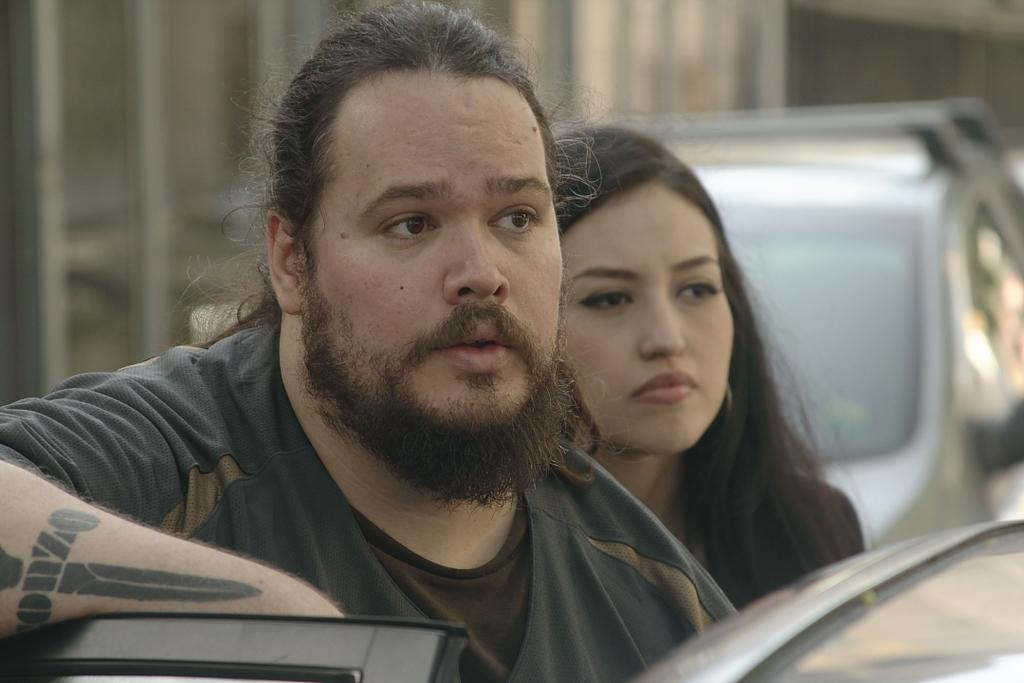Who or what is present in the image? There are people in the image. What are the people doing in the image? The people are staring at something. Can you describe the background of the image? There is a car visible in the background of the image. What type of building is visible in the image? There is no building visible in the image; only people staring at something and a car in the background are present. 